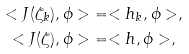<formula> <loc_0><loc_0><loc_500><loc_500>< J ( \zeta _ { k } ) , \phi > & = < h _ { k } , \phi > , \\ < J ( \zeta ) , \phi > & = < h , \phi > ,</formula> 